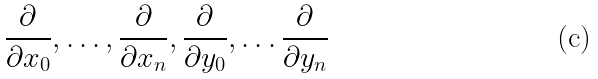Convert formula to latex. <formula><loc_0><loc_0><loc_500><loc_500>\frac { \partial } { \partial x _ { 0 } } , \dots , \frac { \partial } { \partial x _ { n } } , \frac { \partial } { \partial y _ { 0 } } , \dots \frac { \partial } { \partial y _ { n } }</formula> 